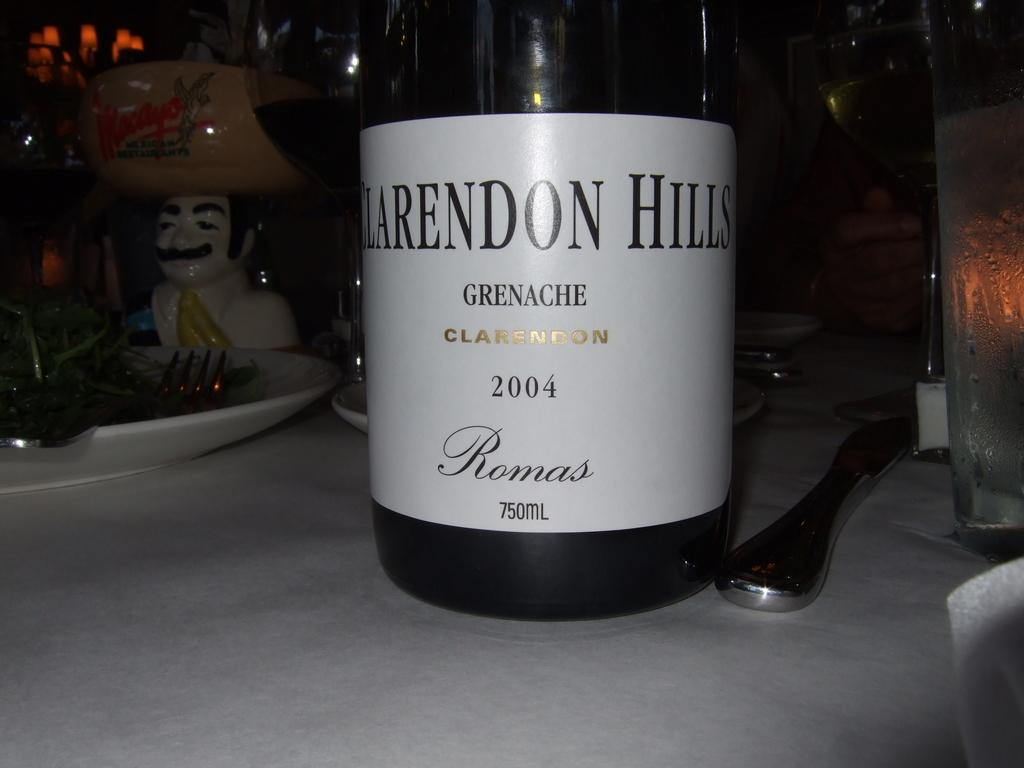<image>
Provide a brief description of the given image. A bottle of Claredon Hills Grenache on a table. 